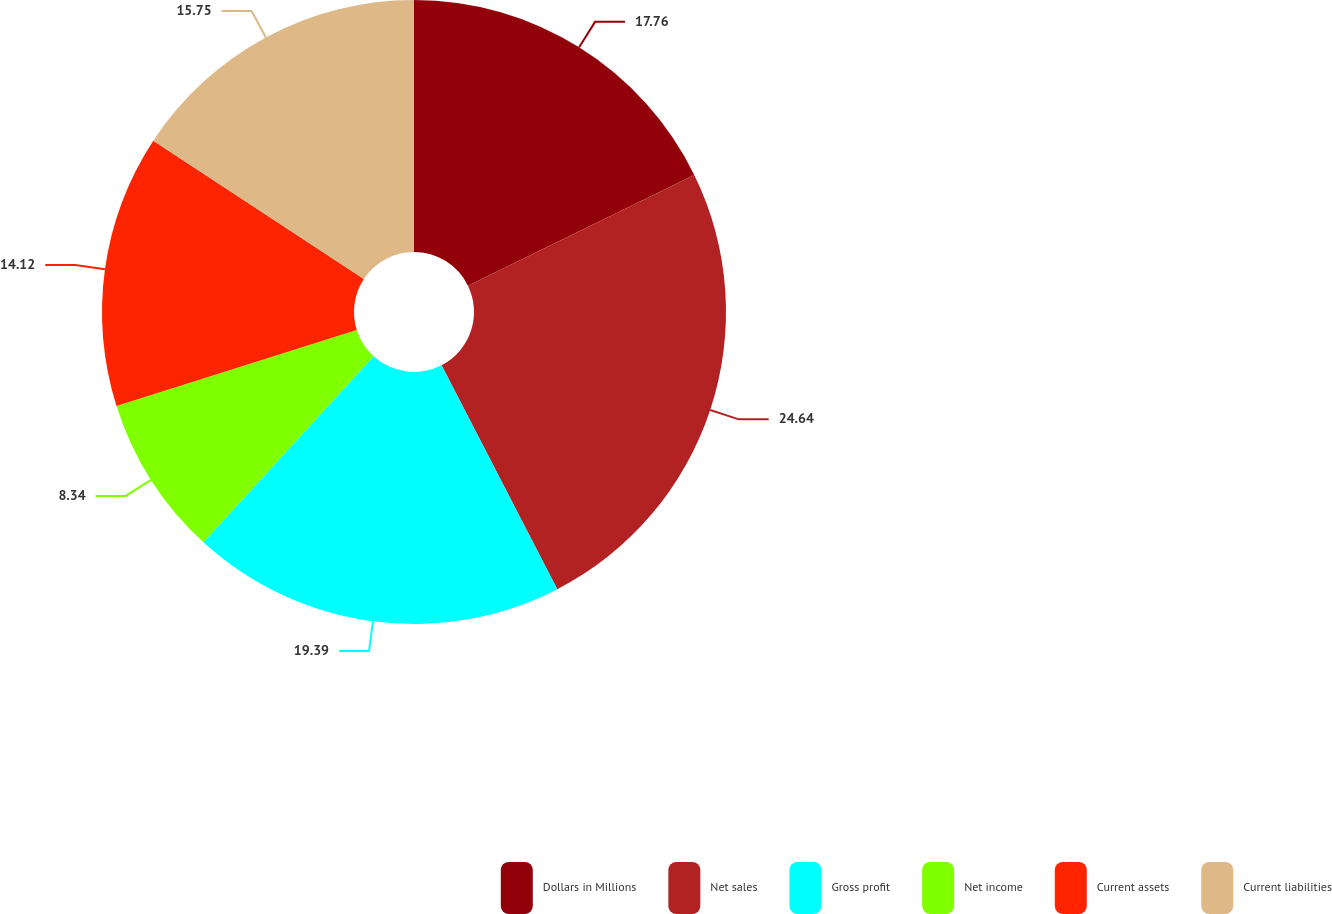<chart> <loc_0><loc_0><loc_500><loc_500><pie_chart><fcel>Dollars in Millions<fcel>Net sales<fcel>Gross profit<fcel>Net income<fcel>Current assets<fcel>Current liabilities<nl><fcel>17.76%<fcel>24.65%<fcel>19.39%<fcel>8.34%<fcel>14.12%<fcel>15.75%<nl></chart> 